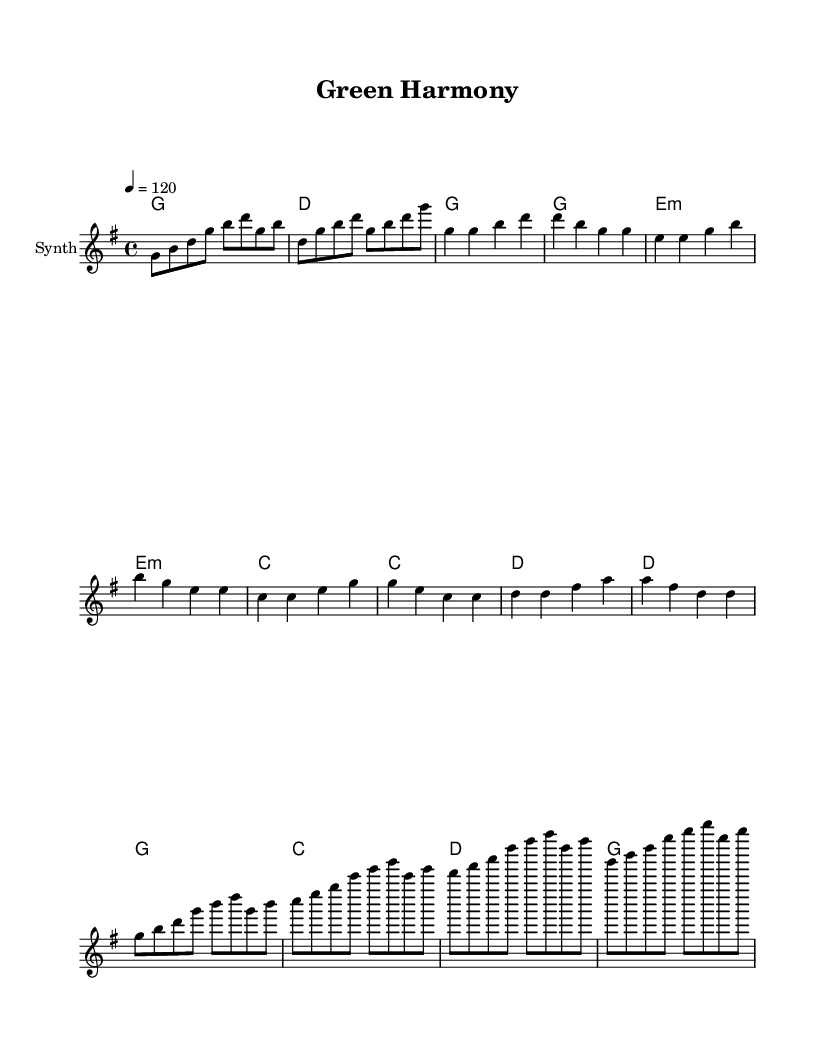what is the key signature of this music? The key signature is G major, which has one sharp (F#). This can be identified from the key signature marking at the beginning of the staff.
Answer: G major what is the time signature of this music? The time signature is 4/4, indicated at the beginning of the piece. This means there are four beats in each measure, and the quarter note gets one beat.
Answer: 4/4 what is the tempo marking given in this music? The tempo marking is 120 beats per minute, which is indicated at the beginning of the score with the instruction "4 = 120". This means the quarter note is played at a speed of 120 beats per minute.
Answer: 120 how many measures are in the verse section? The verse section has four measures, which can be counted from the music notation indicated under the "Verse" part. Each line of music within the section corresponds to one measure.
Answer: 4 what is the last harmony chord noted in the chorus? The last harmony chord noted in the chorus is G major, as seen at the end of the corresponding line in the chord names. Typically, in a chorus, the final line resolves back to the tonic chord, which in this case is G major.
Answer: G which section has the chord progression C - D? The section with the chord progression from C to D is the Pre-Chorus. This is determined by examining the "harmonies" portion of the score, where these specific chords are noted sequentially.
Answer: Pre-Chorus what type of instrument is indicated for this score? The instrument indicated for this score is Synth, as specified in the staff notation at the beginning of the score. This typically refers to synthesizer sounds that are common in K-Pop music.
Answer: Synth 